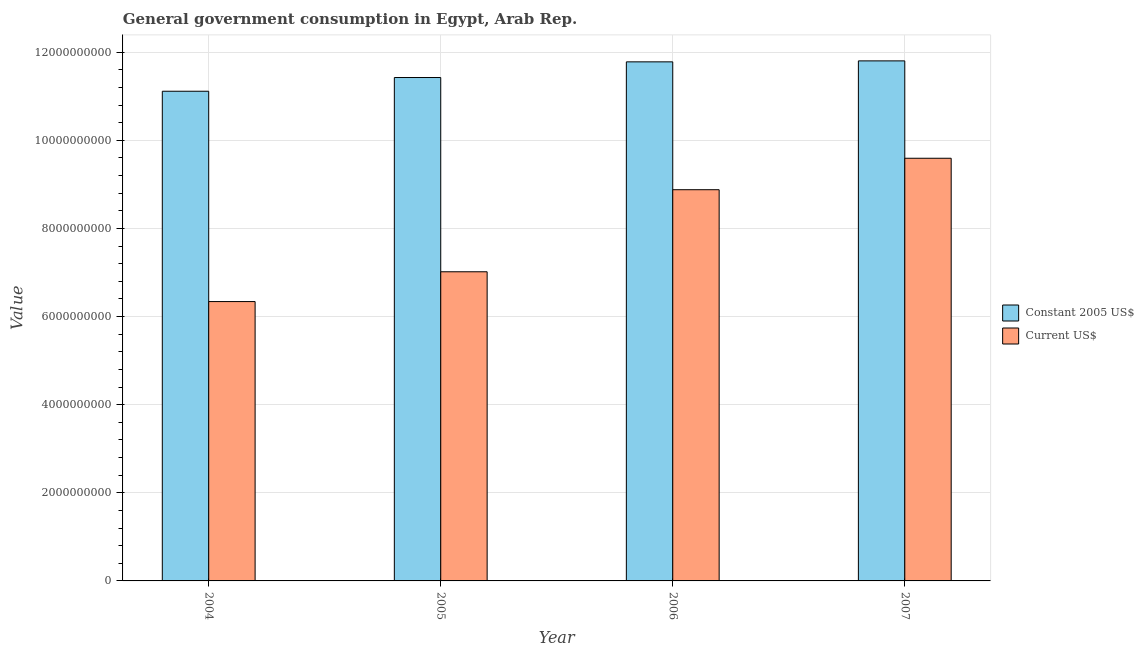Are the number of bars on each tick of the X-axis equal?
Offer a very short reply. Yes. How many bars are there on the 1st tick from the left?
Give a very brief answer. 2. What is the label of the 3rd group of bars from the left?
Provide a short and direct response. 2006. What is the value consumed in current us$ in 2005?
Offer a terse response. 7.02e+09. Across all years, what is the maximum value consumed in current us$?
Your answer should be compact. 9.59e+09. Across all years, what is the minimum value consumed in constant 2005 us$?
Provide a succinct answer. 1.11e+1. In which year was the value consumed in constant 2005 us$ maximum?
Your response must be concise. 2007. What is the total value consumed in current us$ in the graph?
Make the answer very short. 3.18e+1. What is the difference between the value consumed in current us$ in 2004 and that in 2006?
Keep it short and to the point. -2.54e+09. What is the difference between the value consumed in current us$ in 2004 and the value consumed in constant 2005 us$ in 2007?
Provide a short and direct response. -3.25e+09. What is the average value consumed in current us$ per year?
Give a very brief answer. 7.96e+09. In the year 2006, what is the difference between the value consumed in current us$ and value consumed in constant 2005 us$?
Give a very brief answer. 0. In how many years, is the value consumed in current us$ greater than 6400000000?
Provide a succinct answer. 3. What is the ratio of the value consumed in current us$ in 2004 to that in 2006?
Your answer should be compact. 0.71. Is the value consumed in current us$ in 2005 less than that in 2006?
Your answer should be very brief. Yes. Is the difference between the value consumed in constant 2005 us$ in 2005 and 2006 greater than the difference between the value consumed in current us$ in 2005 and 2006?
Provide a short and direct response. No. What is the difference between the highest and the second highest value consumed in constant 2005 us$?
Offer a very short reply. 2.22e+07. What is the difference between the highest and the lowest value consumed in current us$?
Your answer should be very brief. 3.25e+09. Is the sum of the value consumed in constant 2005 us$ in 2004 and 2007 greater than the maximum value consumed in current us$ across all years?
Your answer should be compact. Yes. What does the 2nd bar from the left in 2007 represents?
Your answer should be very brief. Current US$. What does the 1st bar from the right in 2004 represents?
Make the answer very short. Current US$. How many bars are there?
Your answer should be very brief. 8. Are all the bars in the graph horizontal?
Provide a short and direct response. No. What is the difference between two consecutive major ticks on the Y-axis?
Provide a succinct answer. 2.00e+09. Does the graph contain any zero values?
Your answer should be very brief. No. Does the graph contain grids?
Your answer should be very brief. Yes. Where does the legend appear in the graph?
Provide a short and direct response. Center right. How many legend labels are there?
Offer a terse response. 2. How are the legend labels stacked?
Offer a very short reply. Vertical. What is the title of the graph?
Provide a short and direct response. General government consumption in Egypt, Arab Rep. Does "Infant" appear as one of the legend labels in the graph?
Make the answer very short. No. What is the label or title of the Y-axis?
Your answer should be very brief. Value. What is the Value in Constant 2005 US$ in 2004?
Give a very brief answer. 1.11e+1. What is the Value in Current US$ in 2004?
Give a very brief answer. 6.34e+09. What is the Value in Constant 2005 US$ in 2005?
Your answer should be very brief. 1.14e+1. What is the Value in Current US$ in 2005?
Offer a terse response. 7.02e+09. What is the Value of Constant 2005 US$ in 2006?
Give a very brief answer. 1.18e+1. What is the Value of Current US$ in 2006?
Provide a short and direct response. 8.88e+09. What is the Value of Constant 2005 US$ in 2007?
Give a very brief answer. 1.18e+1. What is the Value of Current US$ in 2007?
Give a very brief answer. 9.59e+09. Across all years, what is the maximum Value of Constant 2005 US$?
Ensure brevity in your answer.  1.18e+1. Across all years, what is the maximum Value of Current US$?
Your answer should be very brief. 9.59e+09. Across all years, what is the minimum Value in Constant 2005 US$?
Offer a terse response. 1.11e+1. Across all years, what is the minimum Value in Current US$?
Ensure brevity in your answer.  6.34e+09. What is the total Value in Constant 2005 US$ in the graph?
Give a very brief answer. 4.61e+1. What is the total Value in Current US$ in the graph?
Give a very brief answer. 3.18e+1. What is the difference between the Value of Constant 2005 US$ in 2004 and that in 2005?
Your answer should be very brief. -3.11e+08. What is the difference between the Value of Current US$ in 2004 and that in 2005?
Ensure brevity in your answer.  -6.76e+08. What is the difference between the Value of Constant 2005 US$ in 2004 and that in 2006?
Keep it short and to the point. -6.67e+08. What is the difference between the Value of Current US$ in 2004 and that in 2006?
Make the answer very short. -2.54e+09. What is the difference between the Value of Constant 2005 US$ in 2004 and that in 2007?
Provide a short and direct response. -6.89e+08. What is the difference between the Value of Current US$ in 2004 and that in 2007?
Ensure brevity in your answer.  -3.25e+09. What is the difference between the Value of Constant 2005 US$ in 2005 and that in 2006?
Your answer should be compact. -3.56e+08. What is the difference between the Value in Current US$ in 2005 and that in 2006?
Ensure brevity in your answer.  -1.86e+09. What is the difference between the Value in Constant 2005 US$ in 2005 and that in 2007?
Offer a very short reply. -3.78e+08. What is the difference between the Value of Current US$ in 2005 and that in 2007?
Your answer should be compact. -2.58e+09. What is the difference between the Value in Constant 2005 US$ in 2006 and that in 2007?
Your answer should be very brief. -2.22e+07. What is the difference between the Value of Current US$ in 2006 and that in 2007?
Your answer should be very brief. -7.14e+08. What is the difference between the Value in Constant 2005 US$ in 2004 and the Value in Current US$ in 2005?
Your answer should be very brief. 4.10e+09. What is the difference between the Value in Constant 2005 US$ in 2004 and the Value in Current US$ in 2006?
Provide a succinct answer. 2.23e+09. What is the difference between the Value of Constant 2005 US$ in 2004 and the Value of Current US$ in 2007?
Keep it short and to the point. 1.52e+09. What is the difference between the Value of Constant 2005 US$ in 2005 and the Value of Current US$ in 2006?
Your answer should be compact. 2.55e+09. What is the difference between the Value in Constant 2005 US$ in 2005 and the Value in Current US$ in 2007?
Keep it short and to the point. 1.83e+09. What is the difference between the Value of Constant 2005 US$ in 2006 and the Value of Current US$ in 2007?
Ensure brevity in your answer.  2.19e+09. What is the average Value in Constant 2005 US$ per year?
Your response must be concise. 1.15e+1. What is the average Value of Current US$ per year?
Offer a very short reply. 7.96e+09. In the year 2004, what is the difference between the Value in Constant 2005 US$ and Value in Current US$?
Make the answer very short. 4.77e+09. In the year 2005, what is the difference between the Value in Constant 2005 US$ and Value in Current US$?
Offer a very short reply. 4.41e+09. In the year 2006, what is the difference between the Value of Constant 2005 US$ and Value of Current US$?
Keep it short and to the point. 2.90e+09. In the year 2007, what is the difference between the Value of Constant 2005 US$ and Value of Current US$?
Your response must be concise. 2.21e+09. What is the ratio of the Value of Constant 2005 US$ in 2004 to that in 2005?
Ensure brevity in your answer.  0.97. What is the ratio of the Value in Current US$ in 2004 to that in 2005?
Offer a terse response. 0.9. What is the ratio of the Value in Constant 2005 US$ in 2004 to that in 2006?
Provide a short and direct response. 0.94. What is the ratio of the Value of Current US$ in 2004 to that in 2006?
Ensure brevity in your answer.  0.71. What is the ratio of the Value of Constant 2005 US$ in 2004 to that in 2007?
Your answer should be compact. 0.94. What is the ratio of the Value of Current US$ in 2004 to that in 2007?
Keep it short and to the point. 0.66. What is the ratio of the Value of Constant 2005 US$ in 2005 to that in 2006?
Offer a very short reply. 0.97. What is the ratio of the Value in Current US$ in 2005 to that in 2006?
Keep it short and to the point. 0.79. What is the ratio of the Value of Current US$ in 2005 to that in 2007?
Your answer should be very brief. 0.73. What is the ratio of the Value of Current US$ in 2006 to that in 2007?
Provide a short and direct response. 0.93. What is the difference between the highest and the second highest Value of Constant 2005 US$?
Keep it short and to the point. 2.22e+07. What is the difference between the highest and the second highest Value in Current US$?
Make the answer very short. 7.14e+08. What is the difference between the highest and the lowest Value of Constant 2005 US$?
Provide a succinct answer. 6.89e+08. What is the difference between the highest and the lowest Value in Current US$?
Ensure brevity in your answer.  3.25e+09. 